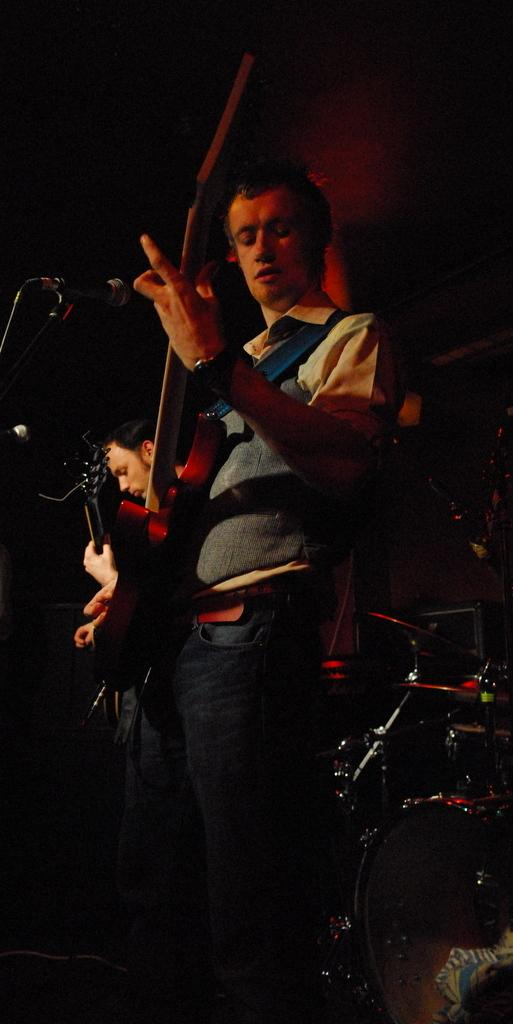What is the man in the image doing? The man is standing and playing a guitar. What object is in front of the man? There is a microphone in front of the man. Can you describe the background of the image? The background of the image is dark. Are there any other people visible in the image? Yes, there is another person in the background of the image. What type of scale is the man using to weigh the guitar in the image? There is no scale present in the image, and the man is not using any scale to weigh the guitar. 